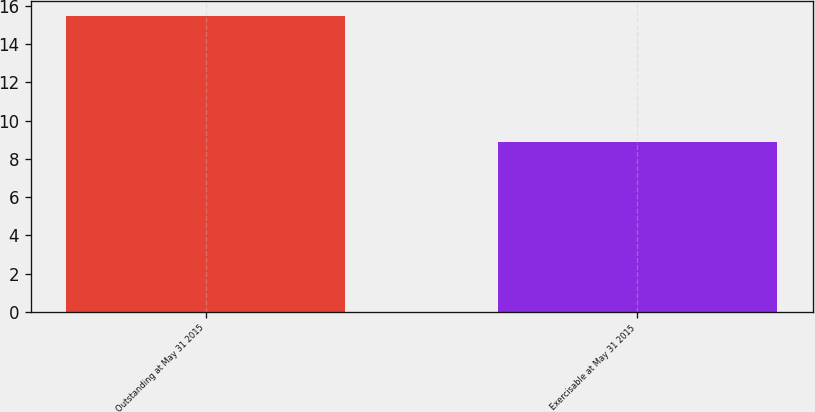<chart> <loc_0><loc_0><loc_500><loc_500><bar_chart><fcel>Outstanding at May 31 2015<fcel>Exercisable at May 31 2015<nl><fcel>15.5<fcel>8.9<nl></chart> 